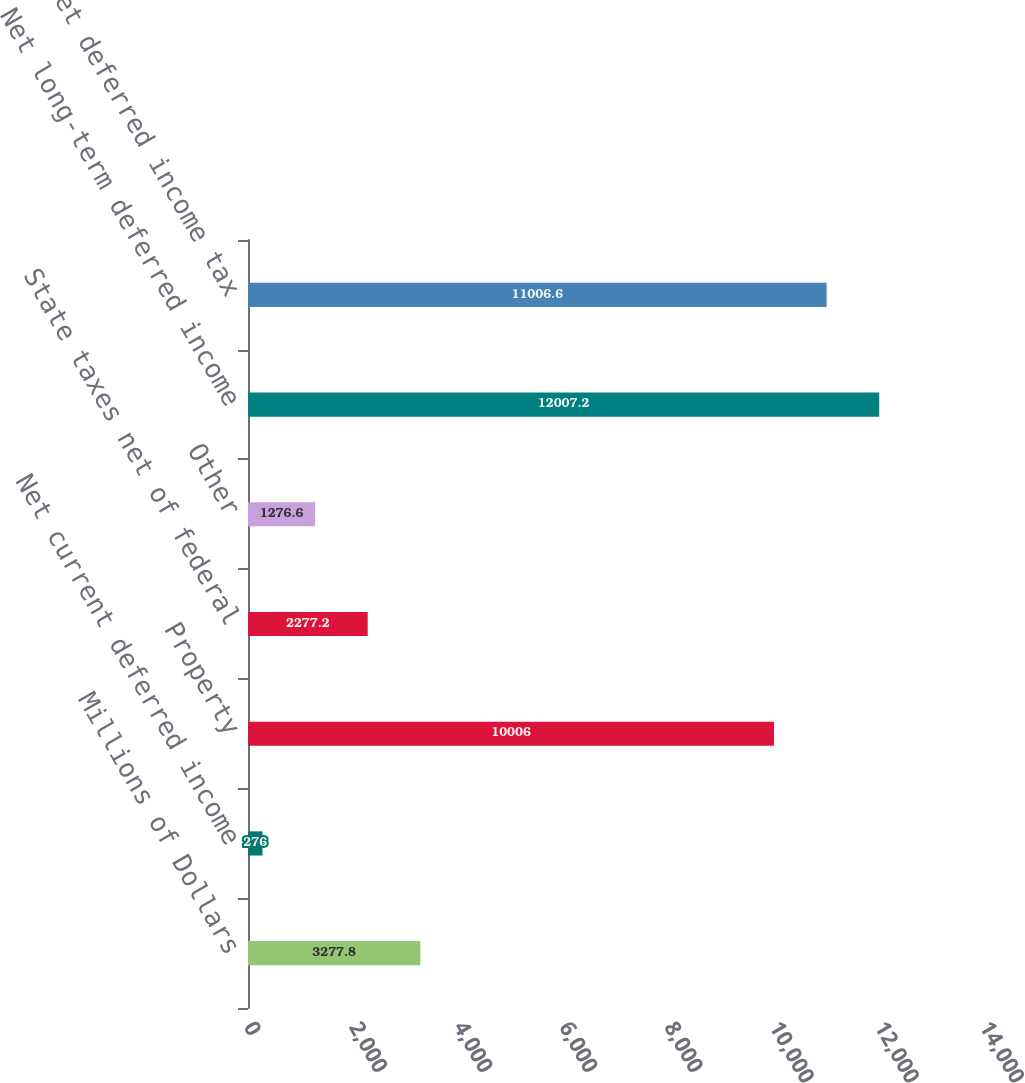<chart> <loc_0><loc_0><loc_500><loc_500><bar_chart><fcel>Millions of Dollars<fcel>Net current deferred income<fcel>Property<fcel>State taxes net of federal<fcel>Other<fcel>Net long-term deferred income<fcel>Net deferred income tax<nl><fcel>3277.8<fcel>276<fcel>10006<fcel>2277.2<fcel>1276.6<fcel>12007.2<fcel>11006.6<nl></chart> 